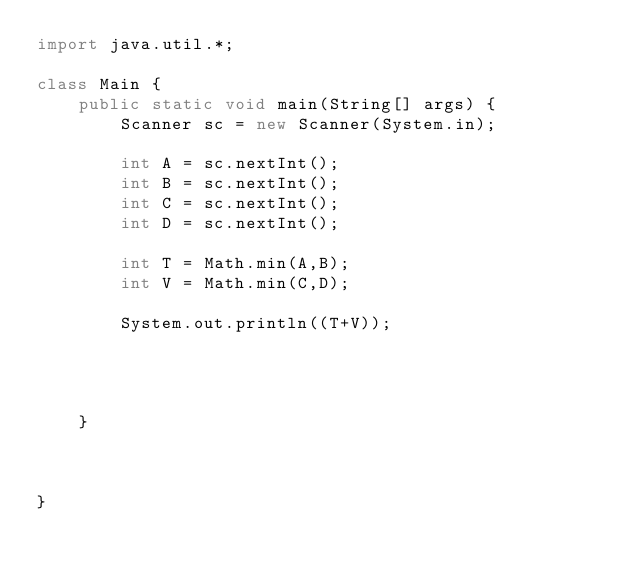Convert code to text. <code><loc_0><loc_0><loc_500><loc_500><_Java_>import java.util.*;

class Main {
    public static void main(String[] args) {
        Scanner sc = new Scanner(System.in);

        int A = sc.nextInt();
        int B = sc.nextInt();
        int C = sc.nextInt();
        int D = sc.nextInt();

        int T = Math.min(A,B);
        int V = Math.min(C,D);

        System.out.println((T+V));

    
    
    
    }



}</code> 